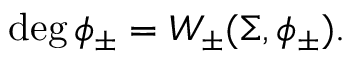<formula> <loc_0><loc_0><loc_500><loc_500>\deg \phi _ { \pm } = W _ { \pm } ( \Sigma , \phi _ { \pm } ) .</formula> 